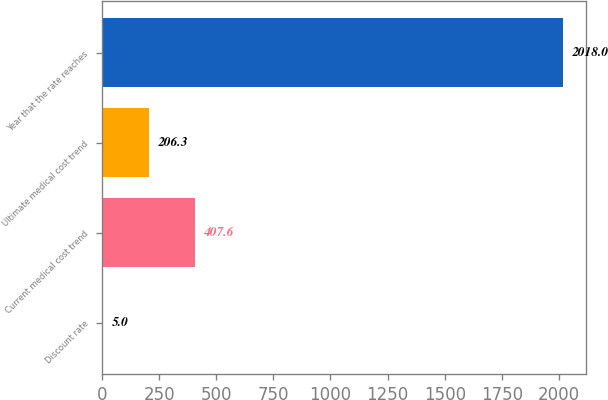Convert chart. <chart><loc_0><loc_0><loc_500><loc_500><bar_chart><fcel>Discount rate<fcel>Current medical cost trend<fcel>Ultimate medical cost trend<fcel>Year that the rate reaches<nl><fcel>5<fcel>407.6<fcel>206.3<fcel>2018<nl></chart> 